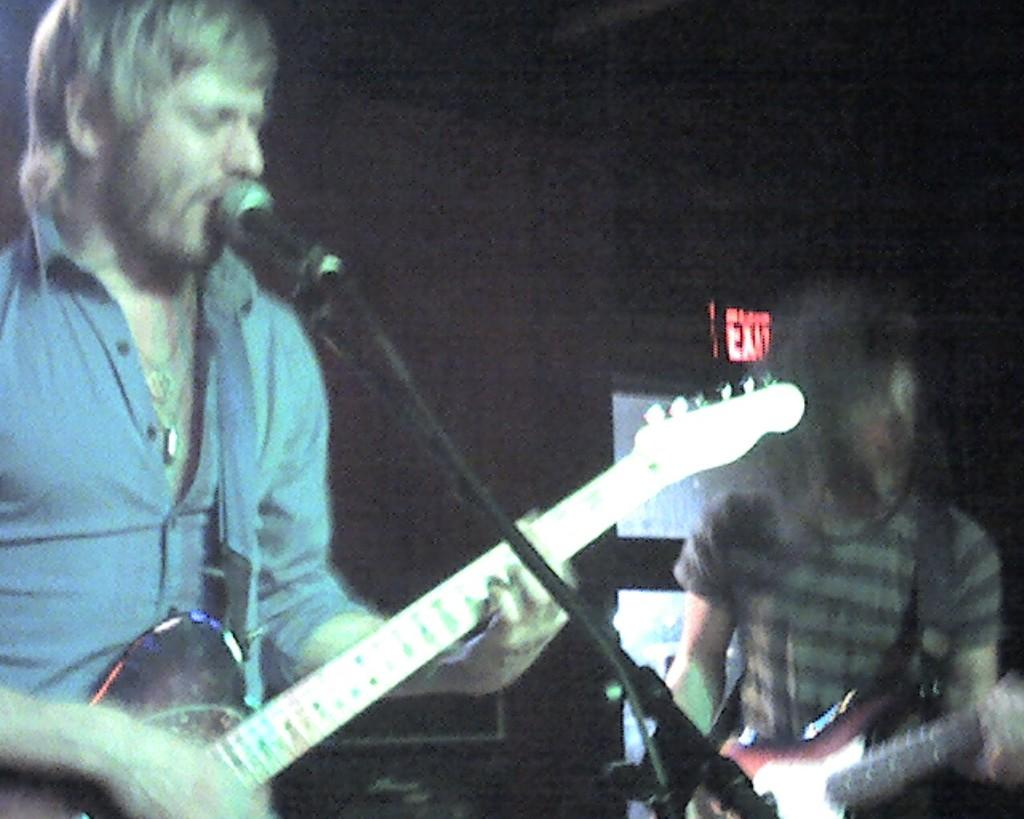What is the main subject of the image? The main subject of the image is a group of people. What are the people doing in the image? The people are sitting around a table. What is on the table in the image? There is a cake with candles on the table. What type of government is depicted in the image? There is no government depicted in the image; it features a group of people sitting around a table with a cake and candles. What kind of tools does the carpenter have in the image? There is no carpenter present in the image; it features a group of people sitting around a table with a cake and candles. 